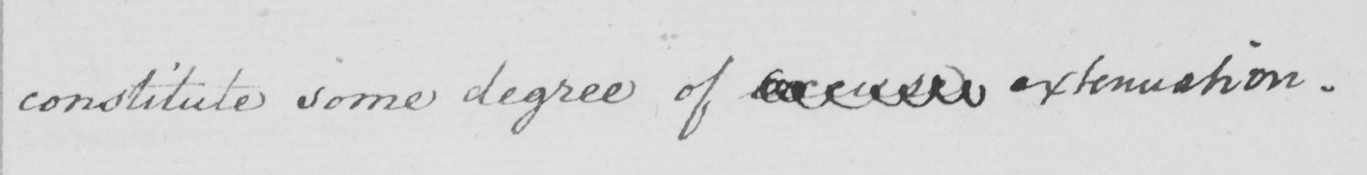What text is written in this handwritten line? constitute some degree of excuse extenuation. 